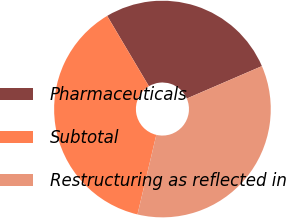<chart> <loc_0><loc_0><loc_500><loc_500><pie_chart><fcel>Pharmaceuticals<fcel>Subtotal<fcel>Restructuring as reflected in<nl><fcel>27.04%<fcel>37.78%<fcel>35.19%<nl></chart> 